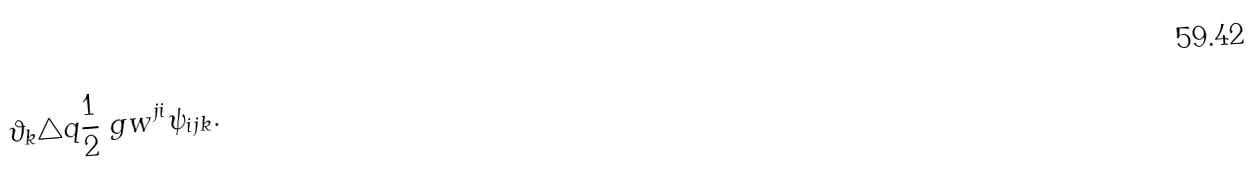Convert formula to latex. <formula><loc_0><loc_0><loc_500><loc_500>\vartheta _ { k } & \triangle q \frac { 1 } { 2 } \ g w ^ { j i } \psi _ { i j k } .</formula> 